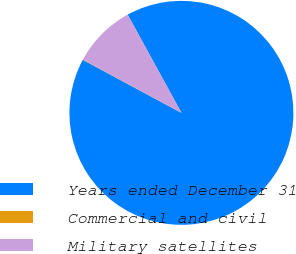<chart> <loc_0><loc_0><loc_500><loc_500><pie_chart><fcel>Years ended December 31<fcel>Commercial and civil<fcel>Military satellites<nl><fcel>90.83%<fcel>0.05%<fcel>9.12%<nl></chart> 